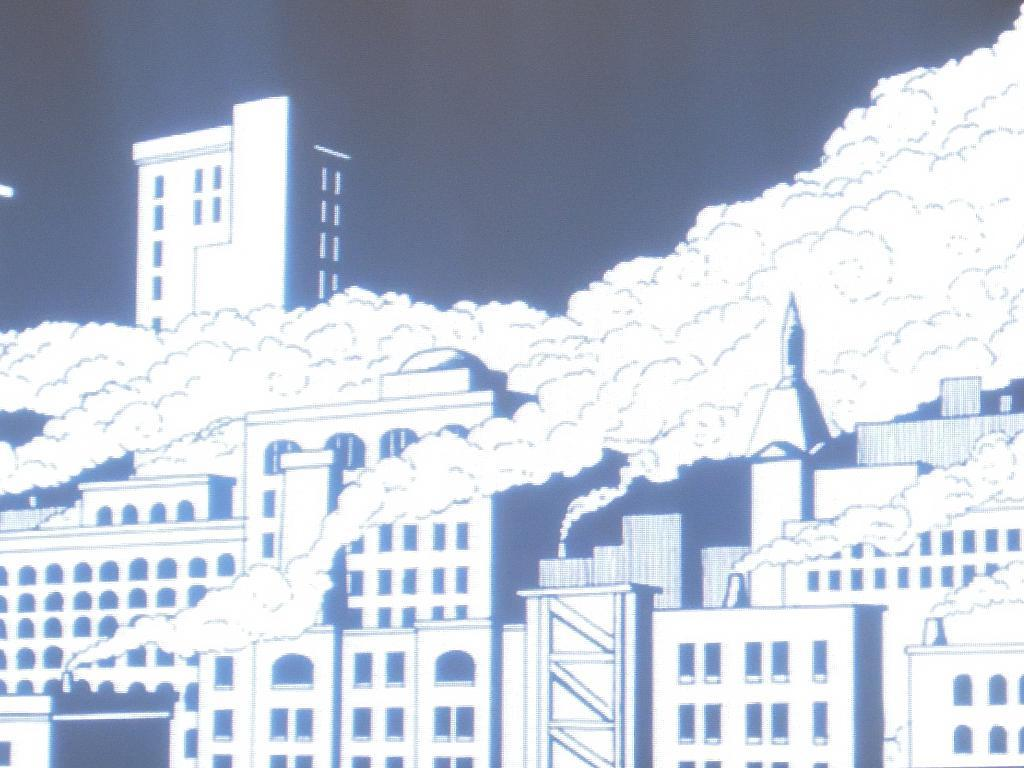What type of image is being shown? The image is an edited image. What can be seen in the image? There are buildings of a factory in the image. What is happening with the factory buildings? The factory buildings are releasing smoke. What type of fish can be seen swimming in the smoke released by the factory buildings? There are no fish present in the image, as it features factory buildings releasing smoke. 